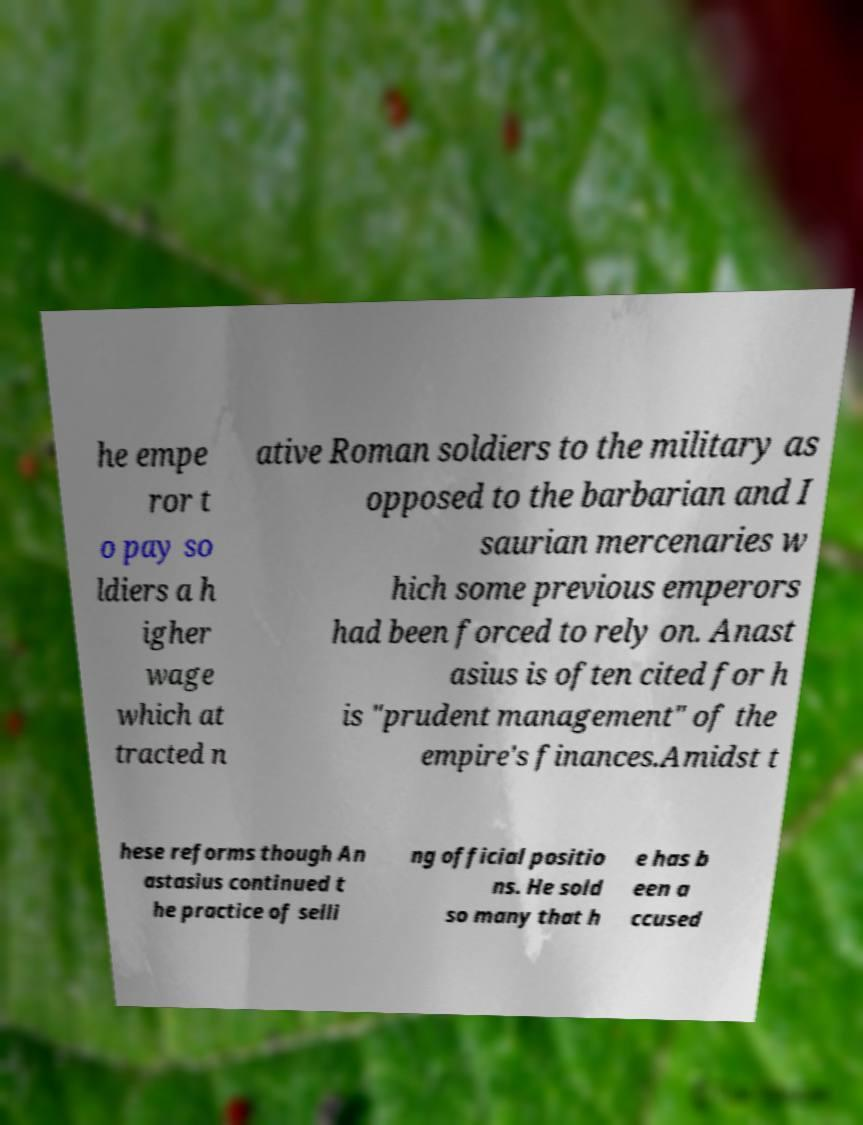I need the written content from this picture converted into text. Can you do that? he empe ror t o pay so ldiers a h igher wage which at tracted n ative Roman soldiers to the military as opposed to the barbarian and I saurian mercenaries w hich some previous emperors had been forced to rely on. Anast asius is often cited for h is "prudent management" of the empire's finances.Amidst t hese reforms though An astasius continued t he practice of selli ng official positio ns. He sold so many that h e has b een a ccused 